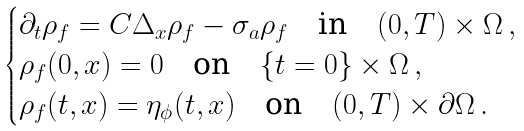<formula> <loc_0><loc_0><loc_500><loc_500>\begin{cases} \partial _ { t } \rho _ { f } = C \Delta _ { x } \rho _ { f } - \sigma _ { a } \rho _ { f } \quad \text {in} \quad ( 0 , T ) \times \Omega \, , \\ \rho _ { f } ( 0 , x ) = 0 \quad \text {on} \quad \{ t = 0 \} \times \Omega \, , \\ \rho _ { f } ( t , x ) = \eta _ { \phi } ( t , x ) \quad \text {on} \quad ( 0 , T ) \times \partial \Omega \, . \end{cases}</formula> 